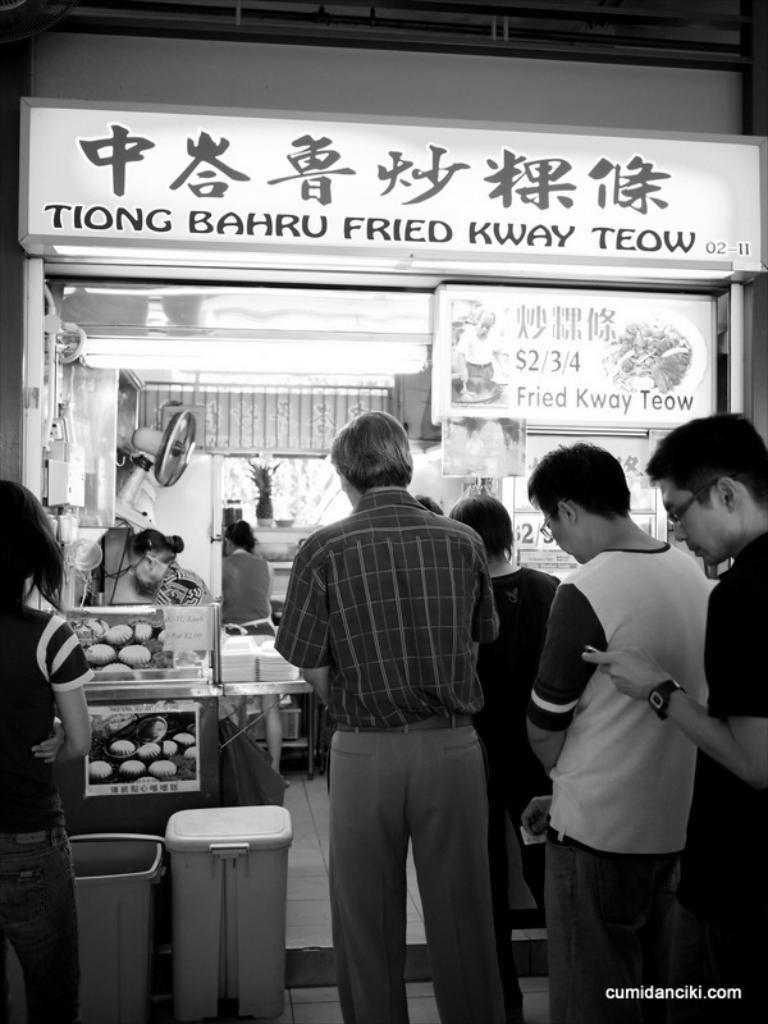Name this food vendor?
Keep it short and to the point. Tiong bahru fried kway teow. How much does the least expensive food item cost?
Offer a terse response. $2. 